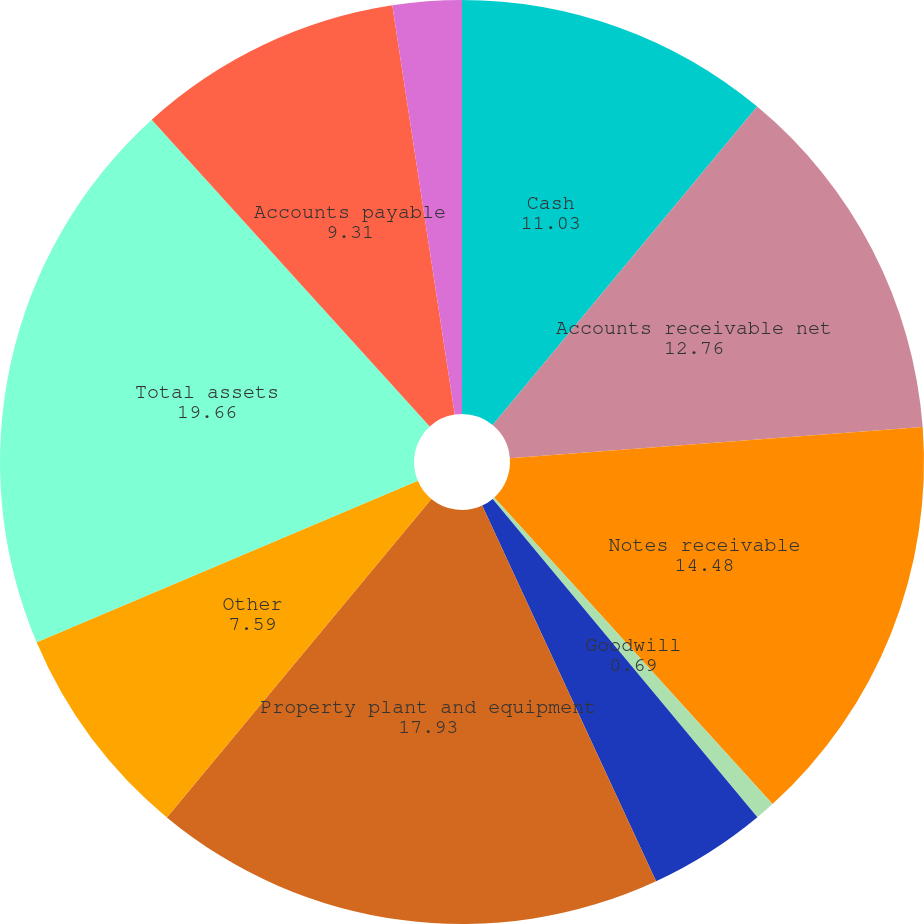Convert chart to OTSL. <chart><loc_0><loc_0><loc_500><loc_500><pie_chart><fcel>Cash<fcel>Accounts receivable net<fcel>Notes receivable<fcel>Goodwill<fcel>Investments<fcel>Property plant and equipment<fcel>Other<fcel>Total assets<fcel>Accounts payable<fcel>Accrued taxes<nl><fcel>11.03%<fcel>12.76%<fcel>14.48%<fcel>0.69%<fcel>4.14%<fcel>17.93%<fcel>7.59%<fcel>19.66%<fcel>9.31%<fcel>2.41%<nl></chart> 